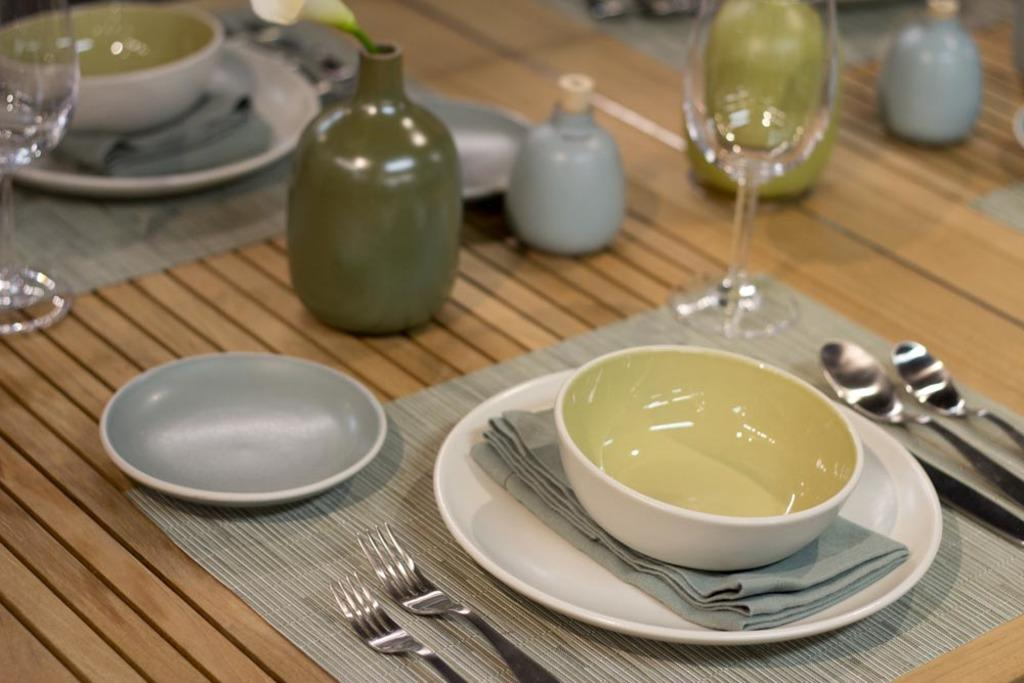What is covering the table in the image? There is a mat on the table. What type of dishware can be seen on the table? There are bowls, a plate, and glasses on the table. What utensils are present on the table? There are spoons on the table. What decorative item is on the table? There is a flower in a vase on the table. What type of fabric is on the table? There is a cloth on the table. What is the income of the person who owns the bun in the image? There is no bun present in the image, and therefore no information about the owner's income can be determined. 